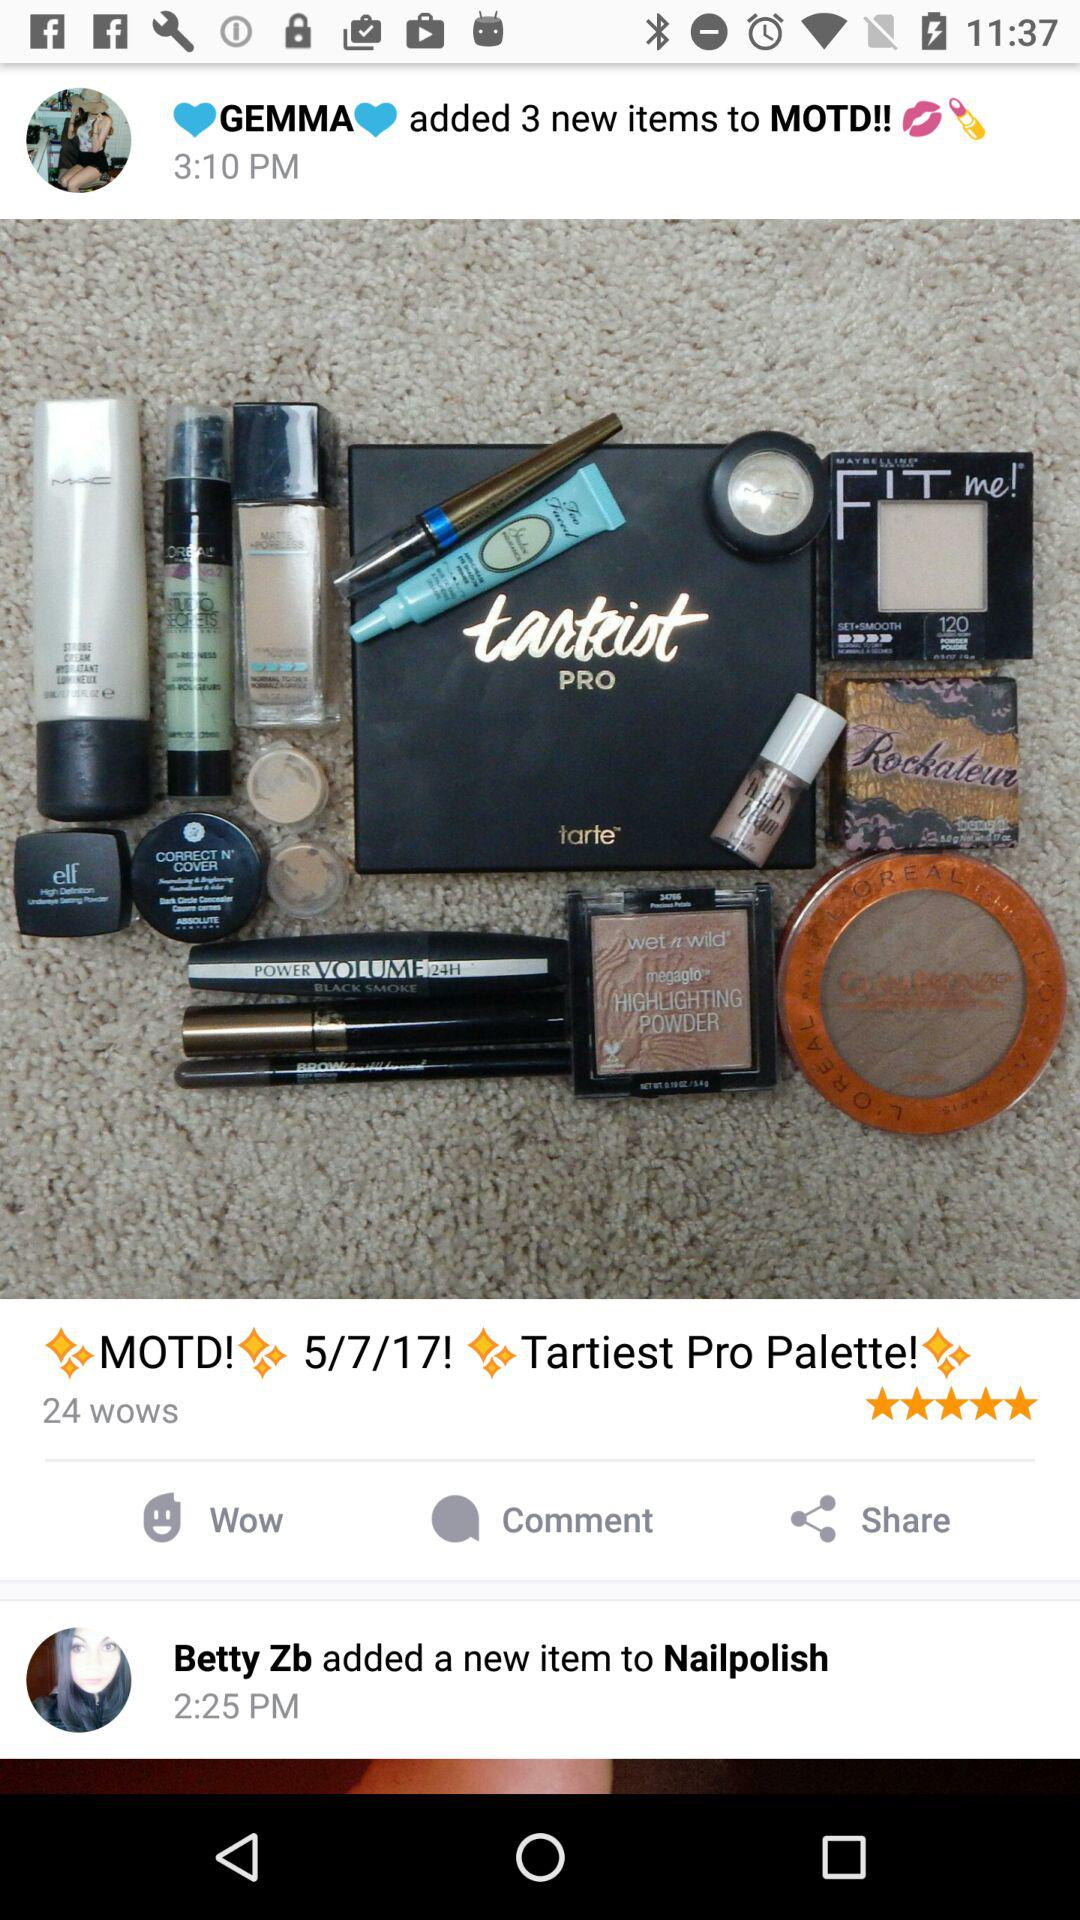How many items did Gemma add to MOTD? Gemma added 3 new items to MOTD. 